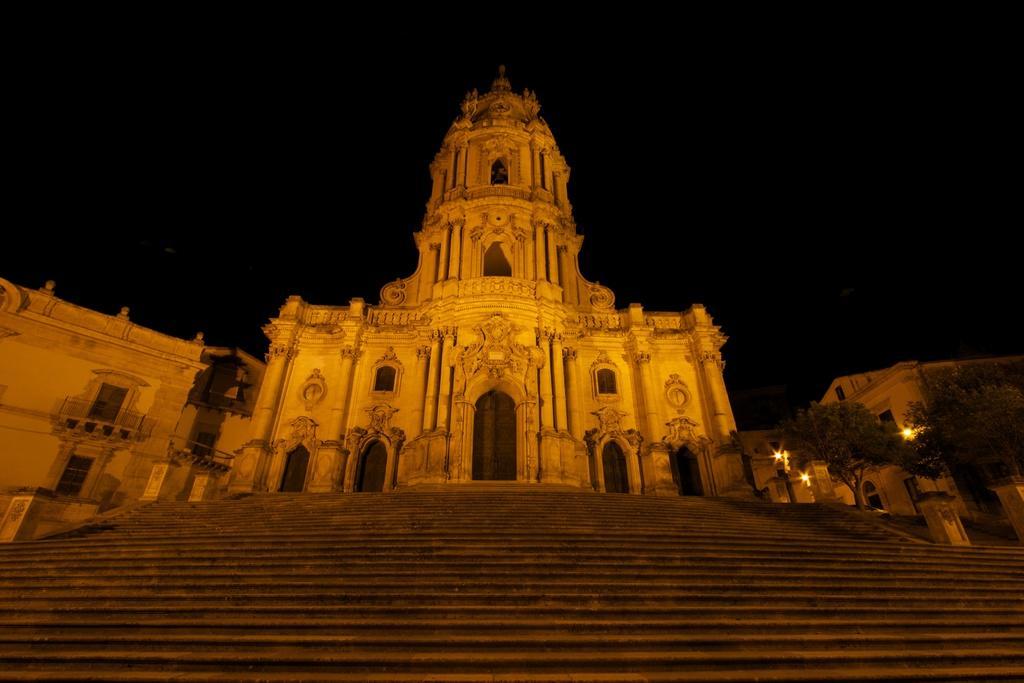Can you describe this image briefly? In this image we can see a building, steps, trees, and lights. In the background there is sky. 